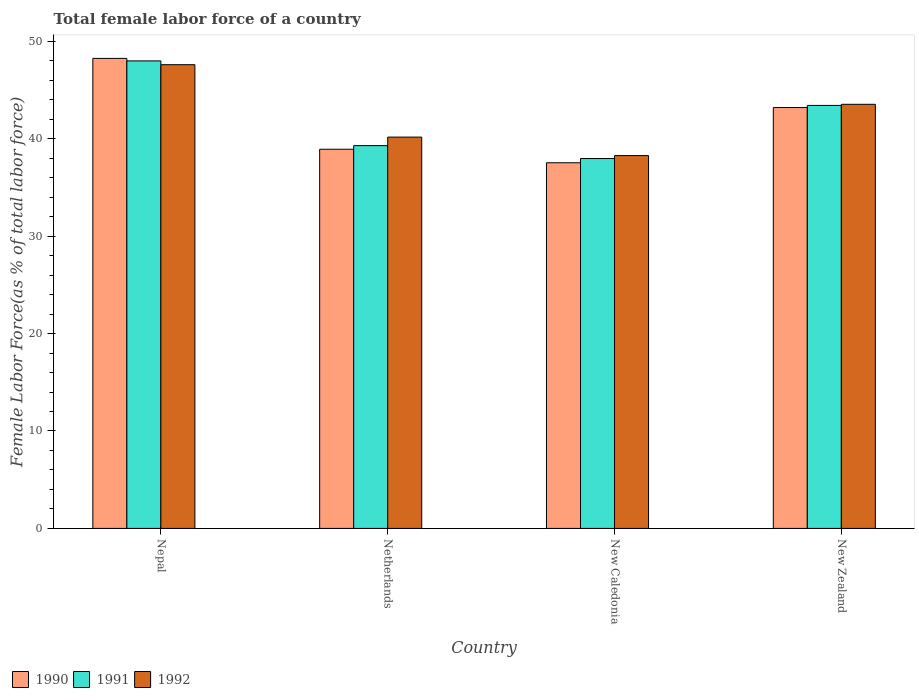How many different coloured bars are there?
Offer a very short reply. 3. How many groups of bars are there?
Keep it short and to the point. 4. Are the number of bars per tick equal to the number of legend labels?
Provide a short and direct response. Yes. What is the label of the 3rd group of bars from the left?
Your answer should be compact. New Caledonia. In how many cases, is the number of bars for a given country not equal to the number of legend labels?
Ensure brevity in your answer.  0. What is the percentage of female labor force in 1990 in Netherlands?
Offer a very short reply. 38.92. Across all countries, what is the maximum percentage of female labor force in 1992?
Keep it short and to the point. 47.6. Across all countries, what is the minimum percentage of female labor force in 1991?
Your response must be concise. 37.96. In which country was the percentage of female labor force in 1990 maximum?
Your answer should be very brief. Nepal. In which country was the percentage of female labor force in 1992 minimum?
Your answer should be very brief. New Caledonia. What is the total percentage of female labor force in 1990 in the graph?
Your response must be concise. 167.89. What is the difference between the percentage of female labor force in 1990 in Netherlands and that in New Zealand?
Give a very brief answer. -4.28. What is the difference between the percentage of female labor force in 1992 in Nepal and the percentage of female labor force in 1990 in New Caledonia?
Ensure brevity in your answer.  10.07. What is the average percentage of female labor force in 1990 per country?
Provide a succinct answer. 41.97. What is the difference between the percentage of female labor force of/in 1991 and percentage of female labor force of/in 1992 in Netherlands?
Keep it short and to the point. -0.88. In how many countries, is the percentage of female labor force in 1991 greater than 28 %?
Your answer should be compact. 4. What is the ratio of the percentage of female labor force in 1991 in Nepal to that in Netherlands?
Provide a succinct answer. 1.22. What is the difference between the highest and the second highest percentage of female labor force in 1991?
Offer a very short reply. 4.13. What is the difference between the highest and the lowest percentage of female labor force in 1990?
Your answer should be very brief. 10.71. Is the sum of the percentage of female labor force in 1990 in New Caledonia and New Zealand greater than the maximum percentage of female labor force in 1992 across all countries?
Ensure brevity in your answer.  Yes. How many bars are there?
Your answer should be compact. 12. How many countries are there in the graph?
Your answer should be compact. 4. What is the difference between two consecutive major ticks on the Y-axis?
Offer a terse response. 10. How many legend labels are there?
Your answer should be very brief. 3. What is the title of the graph?
Keep it short and to the point. Total female labor force of a country. What is the label or title of the Y-axis?
Provide a short and direct response. Female Labor Force(as % of total labor force). What is the Female Labor Force(as % of total labor force) of 1990 in Nepal?
Provide a succinct answer. 48.24. What is the Female Labor Force(as % of total labor force) in 1991 in Nepal?
Give a very brief answer. 47.99. What is the Female Labor Force(as % of total labor force) of 1992 in Nepal?
Provide a succinct answer. 47.6. What is the Female Labor Force(as % of total labor force) of 1990 in Netherlands?
Offer a terse response. 38.92. What is the Female Labor Force(as % of total labor force) in 1991 in Netherlands?
Make the answer very short. 39.29. What is the Female Labor Force(as % of total labor force) in 1992 in Netherlands?
Offer a terse response. 40.16. What is the Female Labor Force(as % of total labor force) of 1990 in New Caledonia?
Keep it short and to the point. 37.53. What is the Female Labor Force(as % of total labor force) in 1991 in New Caledonia?
Make the answer very short. 37.96. What is the Female Labor Force(as % of total labor force) in 1992 in New Caledonia?
Offer a very short reply. 38.27. What is the Female Labor Force(as % of total labor force) in 1990 in New Zealand?
Offer a very short reply. 43.2. What is the Female Labor Force(as % of total labor force) of 1991 in New Zealand?
Provide a succinct answer. 43.42. What is the Female Labor Force(as % of total labor force) of 1992 in New Zealand?
Give a very brief answer. 43.53. Across all countries, what is the maximum Female Labor Force(as % of total labor force) in 1990?
Provide a short and direct response. 48.24. Across all countries, what is the maximum Female Labor Force(as % of total labor force) of 1991?
Provide a short and direct response. 47.99. Across all countries, what is the maximum Female Labor Force(as % of total labor force) of 1992?
Give a very brief answer. 47.6. Across all countries, what is the minimum Female Labor Force(as % of total labor force) of 1990?
Provide a short and direct response. 37.53. Across all countries, what is the minimum Female Labor Force(as % of total labor force) in 1991?
Your answer should be compact. 37.96. Across all countries, what is the minimum Female Labor Force(as % of total labor force) of 1992?
Make the answer very short. 38.27. What is the total Female Labor Force(as % of total labor force) in 1990 in the graph?
Your response must be concise. 167.89. What is the total Female Labor Force(as % of total labor force) of 1991 in the graph?
Your answer should be compact. 168.65. What is the total Female Labor Force(as % of total labor force) in 1992 in the graph?
Ensure brevity in your answer.  169.56. What is the difference between the Female Labor Force(as % of total labor force) of 1990 in Nepal and that in Netherlands?
Provide a succinct answer. 9.33. What is the difference between the Female Labor Force(as % of total labor force) of 1991 in Nepal and that in Netherlands?
Your answer should be very brief. 8.7. What is the difference between the Female Labor Force(as % of total labor force) in 1992 in Nepal and that in Netherlands?
Provide a succinct answer. 7.43. What is the difference between the Female Labor Force(as % of total labor force) of 1990 in Nepal and that in New Caledonia?
Make the answer very short. 10.71. What is the difference between the Female Labor Force(as % of total labor force) of 1991 in Nepal and that in New Caledonia?
Ensure brevity in your answer.  10.02. What is the difference between the Female Labor Force(as % of total labor force) in 1992 in Nepal and that in New Caledonia?
Offer a terse response. 9.33. What is the difference between the Female Labor Force(as % of total labor force) of 1990 in Nepal and that in New Zealand?
Your answer should be compact. 5.05. What is the difference between the Female Labor Force(as % of total labor force) of 1991 in Nepal and that in New Zealand?
Your response must be concise. 4.57. What is the difference between the Female Labor Force(as % of total labor force) in 1992 in Nepal and that in New Zealand?
Keep it short and to the point. 4.07. What is the difference between the Female Labor Force(as % of total labor force) of 1990 in Netherlands and that in New Caledonia?
Provide a short and direct response. 1.39. What is the difference between the Female Labor Force(as % of total labor force) of 1991 in Netherlands and that in New Caledonia?
Offer a terse response. 1.32. What is the difference between the Female Labor Force(as % of total labor force) of 1992 in Netherlands and that in New Caledonia?
Make the answer very short. 1.9. What is the difference between the Female Labor Force(as % of total labor force) of 1990 in Netherlands and that in New Zealand?
Give a very brief answer. -4.28. What is the difference between the Female Labor Force(as % of total labor force) of 1991 in Netherlands and that in New Zealand?
Your answer should be compact. -4.13. What is the difference between the Female Labor Force(as % of total labor force) of 1992 in Netherlands and that in New Zealand?
Provide a succinct answer. -3.37. What is the difference between the Female Labor Force(as % of total labor force) of 1990 in New Caledonia and that in New Zealand?
Make the answer very short. -5.67. What is the difference between the Female Labor Force(as % of total labor force) of 1991 in New Caledonia and that in New Zealand?
Provide a short and direct response. -5.45. What is the difference between the Female Labor Force(as % of total labor force) in 1992 in New Caledonia and that in New Zealand?
Keep it short and to the point. -5.26. What is the difference between the Female Labor Force(as % of total labor force) in 1990 in Nepal and the Female Labor Force(as % of total labor force) in 1991 in Netherlands?
Give a very brief answer. 8.96. What is the difference between the Female Labor Force(as % of total labor force) in 1990 in Nepal and the Female Labor Force(as % of total labor force) in 1992 in Netherlands?
Offer a very short reply. 8.08. What is the difference between the Female Labor Force(as % of total labor force) of 1991 in Nepal and the Female Labor Force(as % of total labor force) of 1992 in Netherlands?
Ensure brevity in your answer.  7.82. What is the difference between the Female Labor Force(as % of total labor force) in 1990 in Nepal and the Female Labor Force(as % of total labor force) in 1991 in New Caledonia?
Your answer should be compact. 10.28. What is the difference between the Female Labor Force(as % of total labor force) in 1990 in Nepal and the Female Labor Force(as % of total labor force) in 1992 in New Caledonia?
Keep it short and to the point. 9.98. What is the difference between the Female Labor Force(as % of total labor force) in 1991 in Nepal and the Female Labor Force(as % of total labor force) in 1992 in New Caledonia?
Your answer should be very brief. 9.72. What is the difference between the Female Labor Force(as % of total labor force) in 1990 in Nepal and the Female Labor Force(as % of total labor force) in 1991 in New Zealand?
Offer a terse response. 4.83. What is the difference between the Female Labor Force(as % of total labor force) of 1990 in Nepal and the Female Labor Force(as % of total labor force) of 1992 in New Zealand?
Your answer should be very brief. 4.71. What is the difference between the Female Labor Force(as % of total labor force) of 1991 in Nepal and the Female Labor Force(as % of total labor force) of 1992 in New Zealand?
Give a very brief answer. 4.46. What is the difference between the Female Labor Force(as % of total labor force) of 1990 in Netherlands and the Female Labor Force(as % of total labor force) of 1991 in New Caledonia?
Make the answer very short. 0.95. What is the difference between the Female Labor Force(as % of total labor force) of 1990 in Netherlands and the Female Labor Force(as % of total labor force) of 1992 in New Caledonia?
Ensure brevity in your answer.  0.65. What is the difference between the Female Labor Force(as % of total labor force) in 1991 in Netherlands and the Female Labor Force(as % of total labor force) in 1992 in New Caledonia?
Your response must be concise. 1.02. What is the difference between the Female Labor Force(as % of total labor force) in 1990 in Netherlands and the Female Labor Force(as % of total labor force) in 1991 in New Zealand?
Offer a terse response. -4.5. What is the difference between the Female Labor Force(as % of total labor force) in 1990 in Netherlands and the Female Labor Force(as % of total labor force) in 1992 in New Zealand?
Offer a terse response. -4.61. What is the difference between the Female Labor Force(as % of total labor force) in 1991 in Netherlands and the Female Labor Force(as % of total labor force) in 1992 in New Zealand?
Your response must be concise. -4.24. What is the difference between the Female Labor Force(as % of total labor force) of 1990 in New Caledonia and the Female Labor Force(as % of total labor force) of 1991 in New Zealand?
Provide a succinct answer. -5.89. What is the difference between the Female Labor Force(as % of total labor force) in 1990 in New Caledonia and the Female Labor Force(as % of total labor force) in 1992 in New Zealand?
Your response must be concise. -6. What is the difference between the Female Labor Force(as % of total labor force) in 1991 in New Caledonia and the Female Labor Force(as % of total labor force) in 1992 in New Zealand?
Offer a very short reply. -5.57. What is the average Female Labor Force(as % of total labor force) in 1990 per country?
Make the answer very short. 41.97. What is the average Female Labor Force(as % of total labor force) of 1991 per country?
Make the answer very short. 42.16. What is the average Female Labor Force(as % of total labor force) of 1992 per country?
Offer a terse response. 42.39. What is the difference between the Female Labor Force(as % of total labor force) in 1990 and Female Labor Force(as % of total labor force) in 1991 in Nepal?
Your response must be concise. 0.26. What is the difference between the Female Labor Force(as % of total labor force) in 1990 and Female Labor Force(as % of total labor force) in 1992 in Nepal?
Offer a terse response. 0.65. What is the difference between the Female Labor Force(as % of total labor force) in 1991 and Female Labor Force(as % of total labor force) in 1992 in Nepal?
Provide a succinct answer. 0.39. What is the difference between the Female Labor Force(as % of total labor force) in 1990 and Female Labor Force(as % of total labor force) in 1991 in Netherlands?
Make the answer very short. -0.37. What is the difference between the Female Labor Force(as % of total labor force) of 1990 and Female Labor Force(as % of total labor force) of 1992 in Netherlands?
Offer a terse response. -1.25. What is the difference between the Female Labor Force(as % of total labor force) of 1991 and Female Labor Force(as % of total labor force) of 1992 in Netherlands?
Offer a terse response. -0.88. What is the difference between the Female Labor Force(as % of total labor force) of 1990 and Female Labor Force(as % of total labor force) of 1991 in New Caledonia?
Give a very brief answer. -0.43. What is the difference between the Female Labor Force(as % of total labor force) in 1990 and Female Labor Force(as % of total labor force) in 1992 in New Caledonia?
Your answer should be compact. -0.74. What is the difference between the Female Labor Force(as % of total labor force) in 1991 and Female Labor Force(as % of total labor force) in 1992 in New Caledonia?
Your answer should be very brief. -0.3. What is the difference between the Female Labor Force(as % of total labor force) in 1990 and Female Labor Force(as % of total labor force) in 1991 in New Zealand?
Your response must be concise. -0.22. What is the difference between the Female Labor Force(as % of total labor force) in 1990 and Female Labor Force(as % of total labor force) in 1992 in New Zealand?
Make the answer very short. -0.33. What is the difference between the Female Labor Force(as % of total labor force) of 1991 and Female Labor Force(as % of total labor force) of 1992 in New Zealand?
Make the answer very short. -0.11. What is the ratio of the Female Labor Force(as % of total labor force) in 1990 in Nepal to that in Netherlands?
Your answer should be compact. 1.24. What is the ratio of the Female Labor Force(as % of total labor force) in 1991 in Nepal to that in Netherlands?
Keep it short and to the point. 1.22. What is the ratio of the Female Labor Force(as % of total labor force) in 1992 in Nepal to that in Netherlands?
Provide a short and direct response. 1.19. What is the ratio of the Female Labor Force(as % of total labor force) in 1990 in Nepal to that in New Caledonia?
Provide a short and direct response. 1.29. What is the ratio of the Female Labor Force(as % of total labor force) in 1991 in Nepal to that in New Caledonia?
Keep it short and to the point. 1.26. What is the ratio of the Female Labor Force(as % of total labor force) in 1992 in Nepal to that in New Caledonia?
Provide a short and direct response. 1.24. What is the ratio of the Female Labor Force(as % of total labor force) of 1990 in Nepal to that in New Zealand?
Make the answer very short. 1.12. What is the ratio of the Female Labor Force(as % of total labor force) in 1991 in Nepal to that in New Zealand?
Keep it short and to the point. 1.11. What is the ratio of the Female Labor Force(as % of total labor force) of 1992 in Nepal to that in New Zealand?
Provide a short and direct response. 1.09. What is the ratio of the Female Labor Force(as % of total labor force) in 1991 in Netherlands to that in New Caledonia?
Make the answer very short. 1.03. What is the ratio of the Female Labor Force(as % of total labor force) of 1992 in Netherlands to that in New Caledonia?
Offer a terse response. 1.05. What is the ratio of the Female Labor Force(as % of total labor force) in 1990 in Netherlands to that in New Zealand?
Your answer should be very brief. 0.9. What is the ratio of the Female Labor Force(as % of total labor force) in 1991 in Netherlands to that in New Zealand?
Provide a short and direct response. 0.9. What is the ratio of the Female Labor Force(as % of total labor force) of 1992 in Netherlands to that in New Zealand?
Your response must be concise. 0.92. What is the ratio of the Female Labor Force(as % of total labor force) in 1990 in New Caledonia to that in New Zealand?
Provide a succinct answer. 0.87. What is the ratio of the Female Labor Force(as % of total labor force) in 1991 in New Caledonia to that in New Zealand?
Provide a succinct answer. 0.87. What is the ratio of the Female Labor Force(as % of total labor force) in 1992 in New Caledonia to that in New Zealand?
Your answer should be compact. 0.88. What is the difference between the highest and the second highest Female Labor Force(as % of total labor force) of 1990?
Offer a very short reply. 5.05. What is the difference between the highest and the second highest Female Labor Force(as % of total labor force) of 1991?
Your answer should be very brief. 4.57. What is the difference between the highest and the second highest Female Labor Force(as % of total labor force) of 1992?
Give a very brief answer. 4.07. What is the difference between the highest and the lowest Female Labor Force(as % of total labor force) of 1990?
Provide a succinct answer. 10.71. What is the difference between the highest and the lowest Female Labor Force(as % of total labor force) of 1991?
Your answer should be very brief. 10.02. What is the difference between the highest and the lowest Female Labor Force(as % of total labor force) of 1992?
Your answer should be very brief. 9.33. 